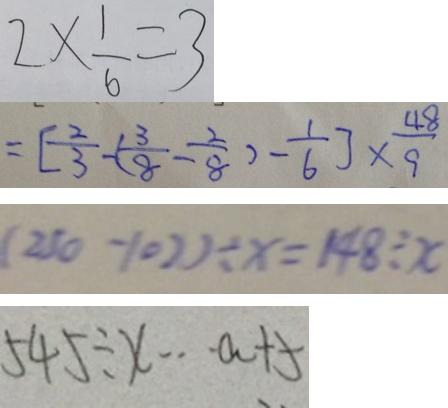Convert formula to latex. <formula><loc_0><loc_0><loc_500><loc_500>2 \times \frac { 1 } { 6 } = 3 
 = [ \frac { 2 } { 3 } - ( \frac { 3 } { 8 } - \frac { 2 } { 8 } ) - \frac { 1 } { 6 } ] \times \frac { 4 8 } { 9 } 
 ( 2 5 0 - 1 0 ) \div x = 1 4 8 \div x 
 5 4 5 \div x \cdots a + 5</formula> 